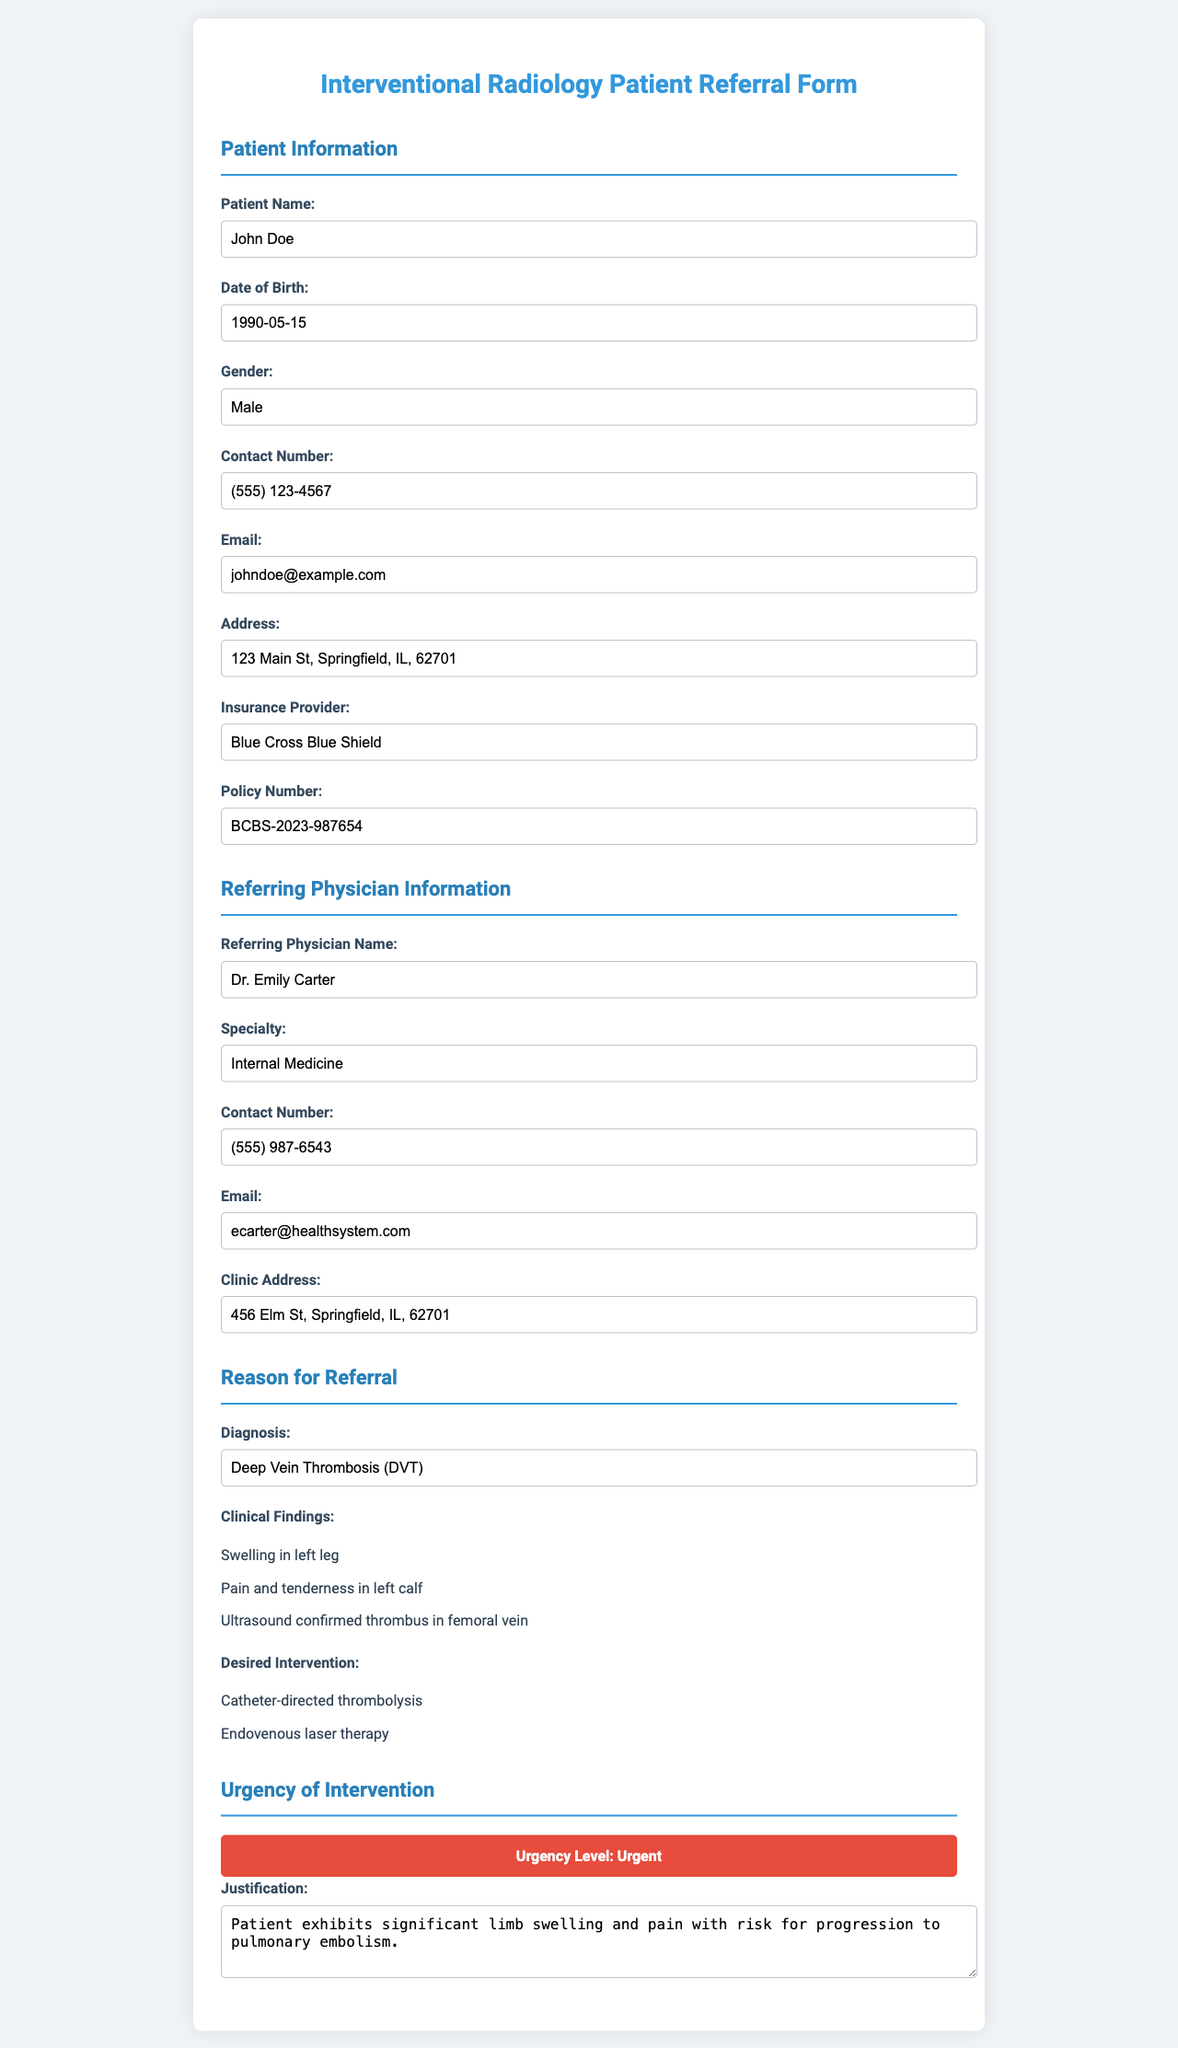what is the patient's name? The patient's name is listed in the Patient Information section of the form.
Answer: John Doe what is the date of birth of the patient? The date of birth can be found under the Patient Information section.
Answer: 1990-05-15 who is the referring physician? The name of the referring physician is mentioned in the Referring Physician Information section.
Answer: Dr. Emily Carter what is the diagnosis for the patient? The diagnosis can be found in the Reason for Referral section.
Answer: Deep Vein Thrombosis (DVT) what is the urgency level of the intervention? The urgency level is stated in the Urgency of Intervention section.
Answer: Urgent what is the justification for the intervention? The justification is provided in the Urgency of Intervention section in a text area.
Answer: Patient exhibits significant limb swelling and pain with risk for progression to pulmonary embolism which insurance provider is mentioned for the patient? The insurance provider's name is listed in the Patient Information section.
Answer: Blue Cross Blue Shield what clinical finding is noted about the patient's left leg? Clinical findings are listed in the Reason for Referral section and detail symptoms related to the patient's condition.
Answer: Swelling in left leg what desired intervention is mentioned for the patient? The desired interventions are provided in the Reason for Referral section, listing possible treatment options.
Answer: Catheter-directed thrombolysis, Endovenous laser therapy 